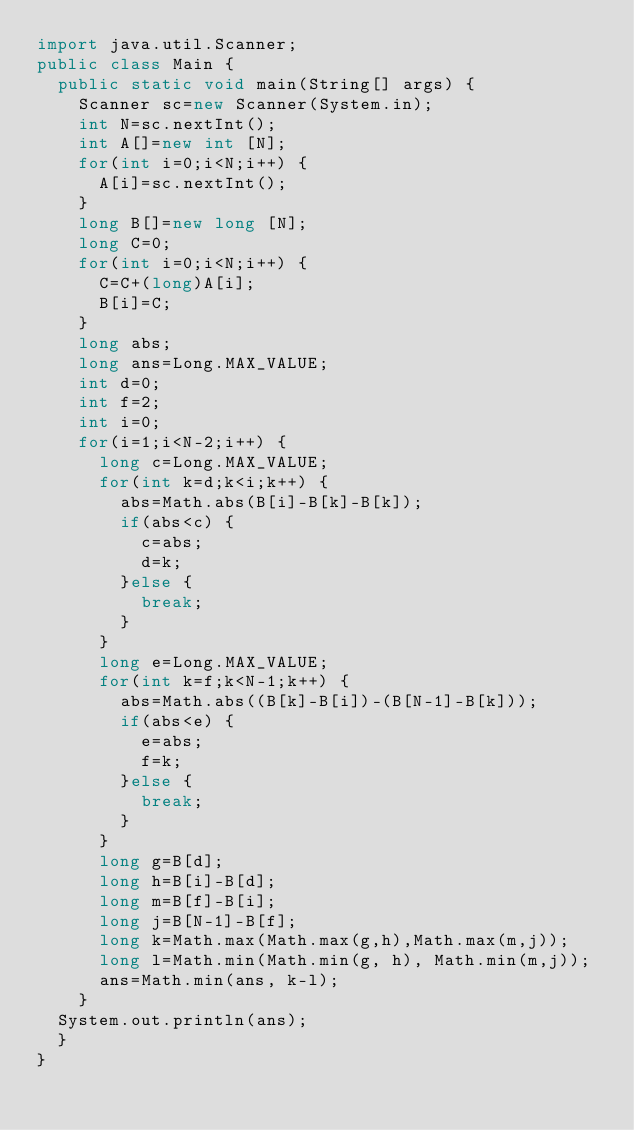Convert code to text. <code><loc_0><loc_0><loc_500><loc_500><_Java_>import java.util.Scanner;
public class Main {
	public static void main(String[] args) {
		Scanner sc=new Scanner(System.in);
		int N=sc.nextInt();
		int A[]=new int [N];
		for(int i=0;i<N;i++) {
			A[i]=sc.nextInt();
		}
		long B[]=new long [N];
		long C=0;
		for(int i=0;i<N;i++) {
			C=C+(long)A[i];
			B[i]=C;
		}
		long abs;
		long ans=Long.MAX_VALUE;
		int d=0;
		int f=2;
		int i=0;
		for(i=1;i<N-2;i++) {
			long c=Long.MAX_VALUE;
			for(int k=d;k<i;k++) {
				abs=Math.abs(B[i]-B[k]-B[k]);
				if(abs<c) {
					c=abs;
					d=k;
				}else {
					break;
				}
			}
			long e=Long.MAX_VALUE;
			for(int k=f;k<N-1;k++) {
				abs=Math.abs((B[k]-B[i])-(B[N-1]-B[k]));
				if(abs<e) {
					e=abs;
					f=k;
				}else {
					break;
				}
			}
			long g=B[d];
			long h=B[i]-B[d];
			long m=B[f]-B[i];
			long j=B[N-1]-B[f];
			long k=Math.max(Math.max(g,h),Math.max(m,j));
			long l=Math.min(Math.min(g, h), Math.min(m,j));
			ans=Math.min(ans, k-l);
		}
	System.out.println(ans);
	}
}
</code> 